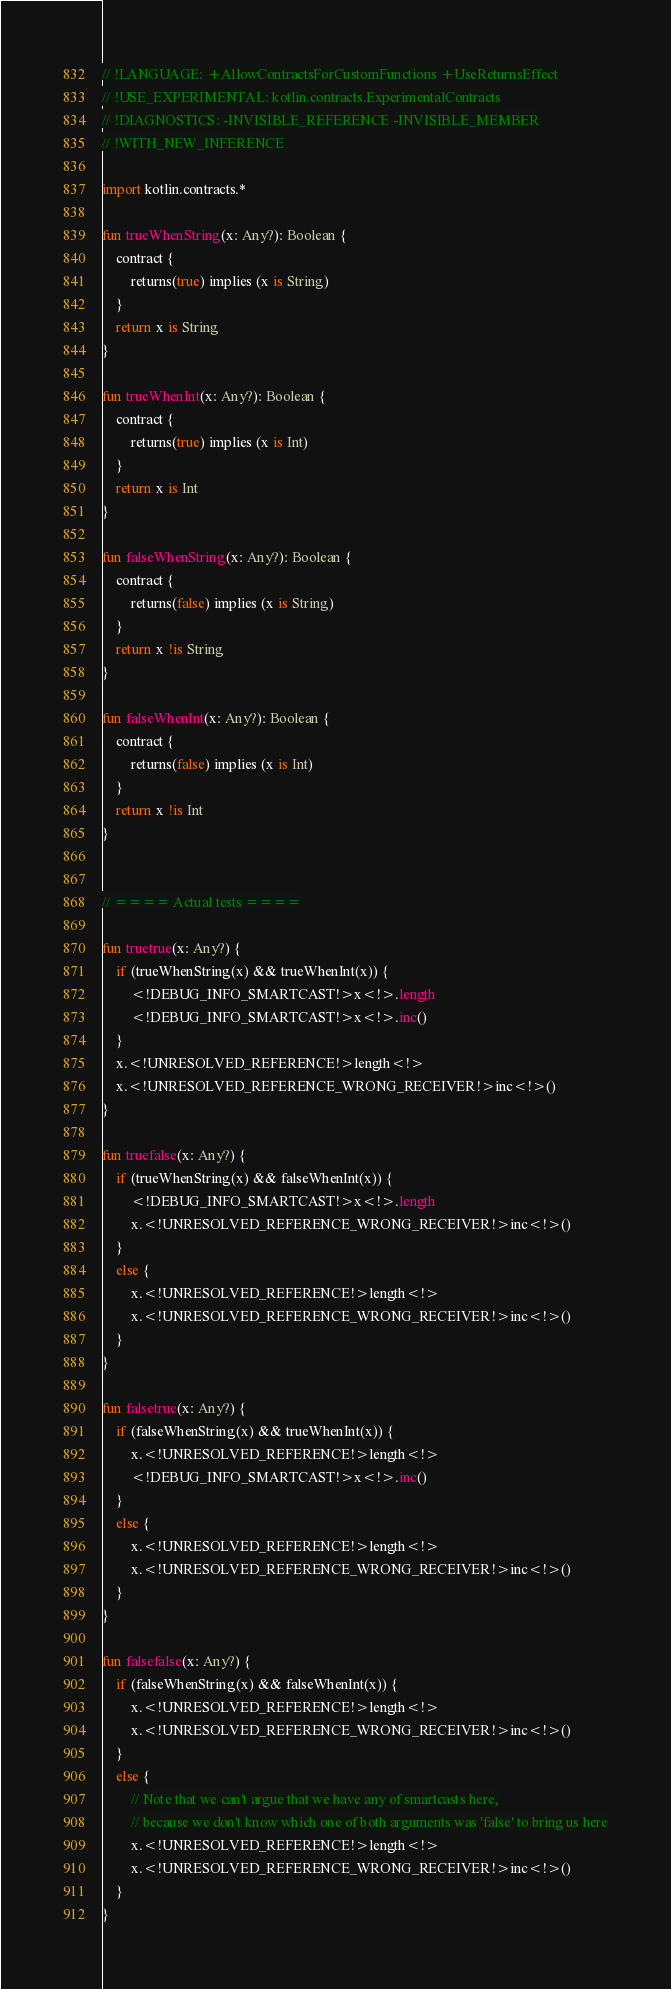Convert code to text. <code><loc_0><loc_0><loc_500><loc_500><_Kotlin_>// !LANGUAGE: +AllowContractsForCustomFunctions +UseReturnsEffect
// !USE_EXPERIMENTAL: kotlin.contracts.ExperimentalContracts
// !DIAGNOSTICS: -INVISIBLE_REFERENCE -INVISIBLE_MEMBER
// !WITH_NEW_INFERENCE

import kotlin.contracts.*

fun trueWhenString(x: Any?): Boolean {
    contract {
        returns(true) implies (x is String)
    }
    return x is String
}

fun trueWhenInt(x: Any?): Boolean {
    contract {
        returns(true) implies (x is Int)
    }
    return x is Int
}

fun falseWhenString(x: Any?): Boolean {
    contract {
        returns(false) implies (x is String)
    }
    return x !is String
}

fun falseWhenInt(x: Any?): Boolean {
    contract {
        returns(false) implies (x is Int)
    }
    return x !is Int
}


// ==== Actual tests ====

fun truetrue(x: Any?) {
    if (trueWhenString(x) && trueWhenInt(x)) {
        <!DEBUG_INFO_SMARTCAST!>x<!>.length
        <!DEBUG_INFO_SMARTCAST!>x<!>.inc()
    }
    x.<!UNRESOLVED_REFERENCE!>length<!>
    x.<!UNRESOLVED_REFERENCE_WRONG_RECEIVER!>inc<!>()
}

fun truefalse(x: Any?) {
    if (trueWhenString(x) && falseWhenInt(x)) {
        <!DEBUG_INFO_SMARTCAST!>x<!>.length
        x.<!UNRESOLVED_REFERENCE_WRONG_RECEIVER!>inc<!>()
    }
    else {
        x.<!UNRESOLVED_REFERENCE!>length<!>
        x.<!UNRESOLVED_REFERENCE_WRONG_RECEIVER!>inc<!>()
    }
}

fun falsetrue(x: Any?) {
    if (falseWhenString(x) && trueWhenInt(x)) {
        x.<!UNRESOLVED_REFERENCE!>length<!>
        <!DEBUG_INFO_SMARTCAST!>x<!>.inc()
    }
    else {
        x.<!UNRESOLVED_REFERENCE!>length<!>
        x.<!UNRESOLVED_REFERENCE_WRONG_RECEIVER!>inc<!>()
    }
}

fun falsefalse(x: Any?) {
    if (falseWhenString(x) && falseWhenInt(x)) {
        x.<!UNRESOLVED_REFERENCE!>length<!>
        x.<!UNRESOLVED_REFERENCE_WRONG_RECEIVER!>inc<!>()
    }
    else {
        // Note that we can't argue that we have any of smartcasts here,
        // because we don't know which one of both arguments was 'false' to bring us here
        x.<!UNRESOLVED_REFERENCE!>length<!>
        x.<!UNRESOLVED_REFERENCE_WRONG_RECEIVER!>inc<!>()
    }
}
</code> 